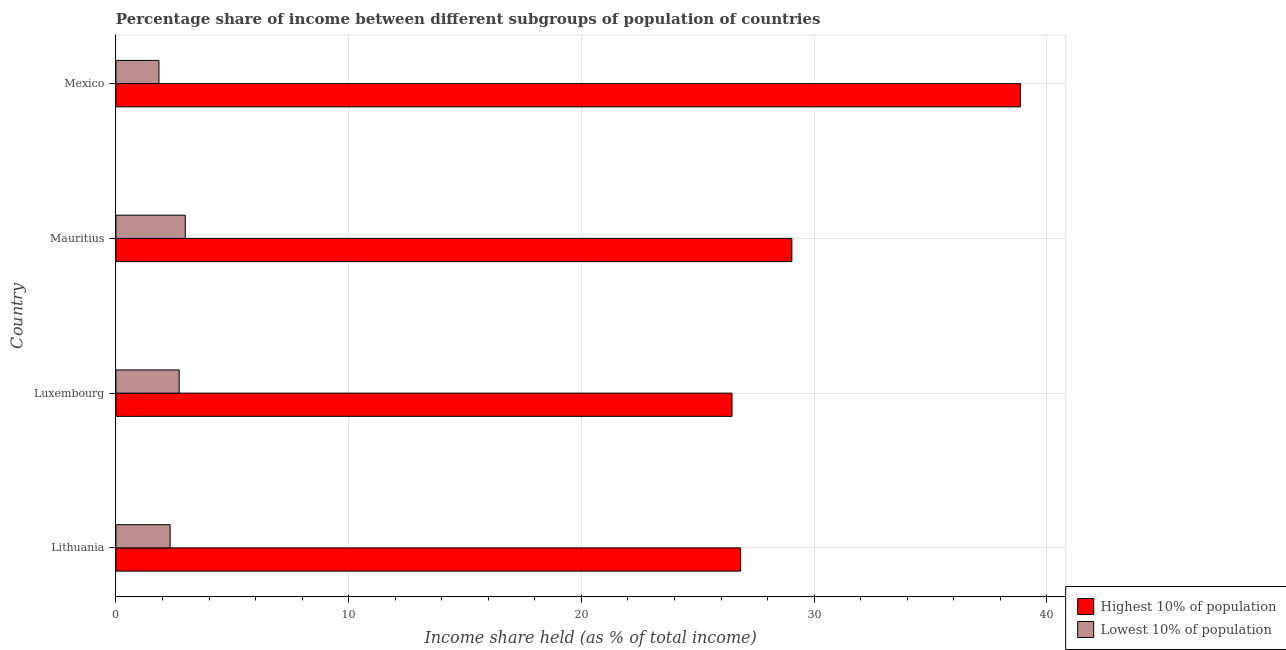Are the number of bars per tick equal to the number of legend labels?
Provide a short and direct response. Yes. Are the number of bars on each tick of the Y-axis equal?
Offer a very short reply. Yes. How many bars are there on the 1st tick from the top?
Make the answer very short. 2. What is the label of the 2nd group of bars from the top?
Offer a very short reply. Mauritius. In how many cases, is the number of bars for a given country not equal to the number of legend labels?
Offer a terse response. 0. What is the income share held by lowest 10% of the population in Mauritius?
Keep it short and to the point. 2.98. Across all countries, what is the maximum income share held by highest 10% of the population?
Keep it short and to the point. 38.86. Across all countries, what is the minimum income share held by highest 10% of the population?
Your answer should be very brief. 26.47. In which country was the income share held by lowest 10% of the population maximum?
Keep it short and to the point. Mauritius. In which country was the income share held by lowest 10% of the population minimum?
Offer a very short reply. Mexico. What is the total income share held by highest 10% of the population in the graph?
Make the answer very short. 121.21. What is the difference between the income share held by highest 10% of the population in Lithuania and that in Mexico?
Offer a terse response. -12.02. What is the difference between the income share held by lowest 10% of the population in Luxembourg and the income share held by highest 10% of the population in Mauritius?
Make the answer very short. -26.32. What is the average income share held by lowest 10% of the population per country?
Provide a succinct answer. 2.47. What is the difference between the income share held by lowest 10% of the population and income share held by highest 10% of the population in Mauritius?
Make the answer very short. -26.06. What is the ratio of the income share held by lowest 10% of the population in Lithuania to that in Mexico?
Provide a short and direct response. 1.26. Is the income share held by highest 10% of the population in Lithuania less than that in Luxembourg?
Your response must be concise. No. Is the difference between the income share held by highest 10% of the population in Lithuania and Mauritius greater than the difference between the income share held by lowest 10% of the population in Lithuania and Mauritius?
Provide a short and direct response. No. What is the difference between the highest and the second highest income share held by lowest 10% of the population?
Your answer should be very brief. 0.26. What is the difference between the highest and the lowest income share held by highest 10% of the population?
Offer a terse response. 12.39. What does the 1st bar from the top in Mauritius represents?
Ensure brevity in your answer.  Lowest 10% of population. What does the 1st bar from the bottom in Luxembourg represents?
Offer a terse response. Highest 10% of population. How many bars are there?
Your response must be concise. 8. How many countries are there in the graph?
Your answer should be compact. 4. What is the difference between two consecutive major ticks on the X-axis?
Ensure brevity in your answer.  10. Are the values on the major ticks of X-axis written in scientific E-notation?
Your answer should be very brief. No. What is the title of the graph?
Offer a terse response. Percentage share of income between different subgroups of population of countries. Does "RDB concessional" appear as one of the legend labels in the graph?
Keep it short and to the point. No. What is the label or title of the X-axis?
Your answer should be very brief. Income share held (as % of total income). What is the label or title of the Y-axis?
Offer a very short reply. Country. What is the Income share held (as % of total income) in Highest 10% of population in Lithuania?
Provide a succinct answer. 26.84. What is the Income share held (as % of total income) of Lowest 10% of population in Lithuania?
Make the answer very short. 2.33. What is the Income share held (as % of total income) of Highest 10% of population in Luxembourg?
Your answer should be very brief. 26.47. What is the Income share held (as % of total income) in Lowest 10% of population in Luxembourg?
Your answer should be compact. 2.72. What is the Income share held (as % of total income) in Highest 10% of population in Mauritius?
Your answer should be very brief. 29.04. What is the Income share held (as % of total income) of Lowest 10% of population in Mauritius?
Make the answer very short. 2.98. What is the Income share held (as % of total income) of Highest 10% of population in Mexico?
Ensure brevity in your answer.  38.86. What is the Income share held (as % of total income) of Lowest 10% of population in Mexico?
Make the answer very short. 1.85. Across all countries, what is the maximum Income share held (as % of total income) in Highest 10% of population?
Your response must be concise. 38.86. Across all countries, what is the maximum Income share held (as % of total income) of Lowest 10% of population?
Give a very brief answer. 2.98. Across all countries, what is the minimum Income share held (as % of total income) of Highest 10% of population?
Your response must be concise. 26.47. Across all countries, what is the minimum Income share held (as % of total income) in Lowest 10% of population?
Provide a succinct answer. 1.85. What is the total Income share held (as % of total income) of Highest 10% of population in the graph?
Offer a very short reply. 121.21. What is the total Income share held (as % of total income) in Lowest 10% of population in the graph?
Your response must be concise. 9.88. What is the difference between the Income share held (as % of total income) of Highest 10% of population in Lithuania and that in Luxembourg?
Make the answer very short. 0.37. What is the difference between the Income share held (as % of total income) in Lowest 10% of population in Lithuania and that in Luxembourg?
Provide a short and direct response. -0.39. What is the difference between the Income share held (as % of total income) of Lowest 10% of population in Lithuania and that in Mauritius?
Your answer should be compact. -0.65. What is the difference between the Income share held (as % of total income) in Highest 10% of population in Lithuania and that in Mexico?
Provide a short and direct response. -12.02. What is the difference between the Income share held (as % of total income) of Lowest 10% of population in Lithuania and that in Mexico?
Your answer should be very brief. 0.48. What is the difference between the Income share held (as % of total income) in Highest 10% of population in Luxembourg and that in Mauritius?
Provide a short and direct response. -2.57. What is the difference between the Income share held (as % of total income) in Lowest 10% of population in Luxembourg and that in Mauritius?
Your response must be concise. -0.26. What is the difference between the Income share held (as % of total income) of Highest 10% of population in Luxembourg and that in Mexico?
Make the answer very short. -12.39. What is the difference between the Income share held (as % of total income) in Lowest 10% of population in Luxembourg and that in Mexico?
Keep it short and to the point. 0.87. What is the difference between the Income share held (as % of total income) in Highest 10% of population in Mauritius and that in Mexico?
Offer a very short reply. -9.82. What is the difference between the Income share held (as % of total income) of Lowest 10% of population in Mauritius and that in Mexico?
Make the answer very short. 1.13. What is the difference between the Income share held (as % of total income) of Highest 10% of population in Lithuania and the Income share held (as % of total income) of Lowest 10% of population in Luxembourg?
Ensure brevity in your answer.  24.12. What is the difference between the Income share held (as % of total income) of Highest 10% of population in Lithuania and the Income share held (as % of total income) of Lowest 10% of population in Mauritius?
Provide a short and direct response. 23.86. What is the difference between the Income share held (as % of total income) in Highest 10% of population in Lithuania and the Income share held (as % of total income) in Lowest 10% of population in Mexico?
Give a very brief answer. 24.99. What is the difference between the Income share held (as % of total income) in Highest 10% of population in Luxembourg and the Income share held (as % of total income) in Lowest 10% of population in Mauritius?
Make the answer very short. 23.49. What is the difference between the Income share held (as % of total income) of Highest 10% of population in Luxembourg and the Income share held (as % of total income) of Lowest 10% of population in Mexico?
Your answer should be very brief. 24.62. What is the difference between the Income share held (as % of total income) of Highest 10% of population in Mauritius and the Income share held (as % of total income) of Lowest 10% of population in Mexico?
Offer a terse response. 27.19. What is the average Income share held (as % of total income) in Highest 10% of population per country?
Give a very brief answer. 30.3. What is the average Income share held (as % of total income) in Lowest 10% of population per country?
Your response must be concise. 2.47. What is the difference between the Income share held (as % of total income) of Highest 10% of population and Income share held (as % of total income) of Lowest 10% of population in Lithuania?
Your response must be concise. 24.51. What is the difference between the Income share held (as % of total income) in Highest 10% of population and Income share held (as % of total income) in Lowest 10% of population in Luxembourg?
Your response must be concise. 23.75. What is the difference between the Income share held (as % of total income) of Highest 10% of population and Income share held (as % of total income) of Lowest 10% of population in Mauritius?
Offer a terse response. 26.06. What is the difference between the Income share held (as % of total income) of Highest 10% of population and Income share held (as % of total income) of Lowest 10% of population in Mexico?
Offer a very short reply. 37.01. What is the ratio of the Income share held (as % of total income) of Lowest 10% of population in Lithuania to that in Luxembourg?
Ensure brevity in your answer.  0.86. What is the ratio of the Income share held (as % of total income) of Highest 10% of population in Lithuania to that in Mauritius?
Offer a terse response. 0.92. What is the ratio of the Income share held (as % of total income) of Lowest 10% of population in Lithuania to that in Mauritius?
Your response must be concise. 0.78. What is the ratio of the Income share held (as % of total income) of Highest 10% of population in Lithuania to that in Mexico?
Ensure brevity in your answer.  0.69. What is the ratio of the Income share held (as % of total income) of Lowest 10% of population in Lithuania to that in Mexico?
Make the answer very short. 1.26. What is the ratio of the Income share held (as % of total income) in Highest 10% of population in Luxembourg to that in Mauritius?
Ensure brevity in your answer.  0.91. What is the ratio of the Income share held (as % of total income) of Lowest 10% of population in Luxembourg to that in Mauritius?
Keep it short and to the point. 0.91. What is the ratio of the Income share held (as % of total income) of Highest 10% of population in Luxembourg to that in Mexico?
Offer a very short reply. 0.68. What is the ratio of the Income share held (as % of total income) of Lowest 10% of population in Luxembourg to that in Mexico?
Offer a very short reply. 1.47. What is the ratio of the Income share held (as % of total income) of Highest 10% of population in Mauritius to that in Mexico?
Your answer should be very brief. 0.75. What is the ratio of the Income share held (as % of total income) in Lowest 10% of population in Mauritius to that in Mexico?
Your response must be concise. 1.61. What is the difference between the highest and the second highest Income share held (as % of total income) in Highest 10% of population?
Make the answer very short. 9.82. What is the difference between the highest and the second highest Income share held (as % of total income) in Lowest 10% of population?
Offer a very short reply. 0.26. What is the difference between the highest and the lowest Income share held (as % of total income) of Highest 10% of population?
Ensure brevity in your answer.  12.39. What is the difference between the highest and the lowest Income share held (as % of total income) in Lowest 10% of population?
Offer a terse response. 1.13. 